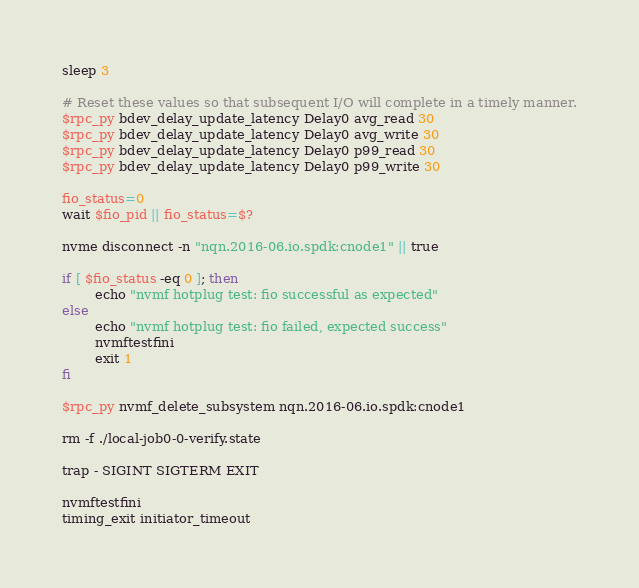Convert code to text. <code><loc_0><loc_0><loc_500><loc_500><_Bash_>
sleep 3

# Reset these values so that subsequent I/O will complete in a timely manner.
$rpc_py bdev_delay_update_latency Delay0 avg_read 30
$rpc_py bdev_delay_update_latency Delay0 avg_write 30
$rpc_py bdev_delay_update_latency Delay0 p99_read 30
$rpc_py bdev_delay_update_latency Delay0 p99_write 30

fio_status=0
wait $fio_pid || fio_status=$?

nvme disconnect -n "nqn.2016-06.io.spdk:cnode1" || true

if [ $fio_status -eq 0 ]; then
        echo "nvmf hotplug test: fio successful as expected"
else
        echo "nvmf hotplug test: fio failed, expected success"
        nvmftestfini
        exit 1
fi

$rpc_py nvmf_delete_subsystem nqn.2016-06.io.spdk:cnode1

rm -f ./local-job0-0-verify.state

trap - SIGINT SIGTERM EXIT

nvmftestfini
timing_exit initiator_timeout
</code> 